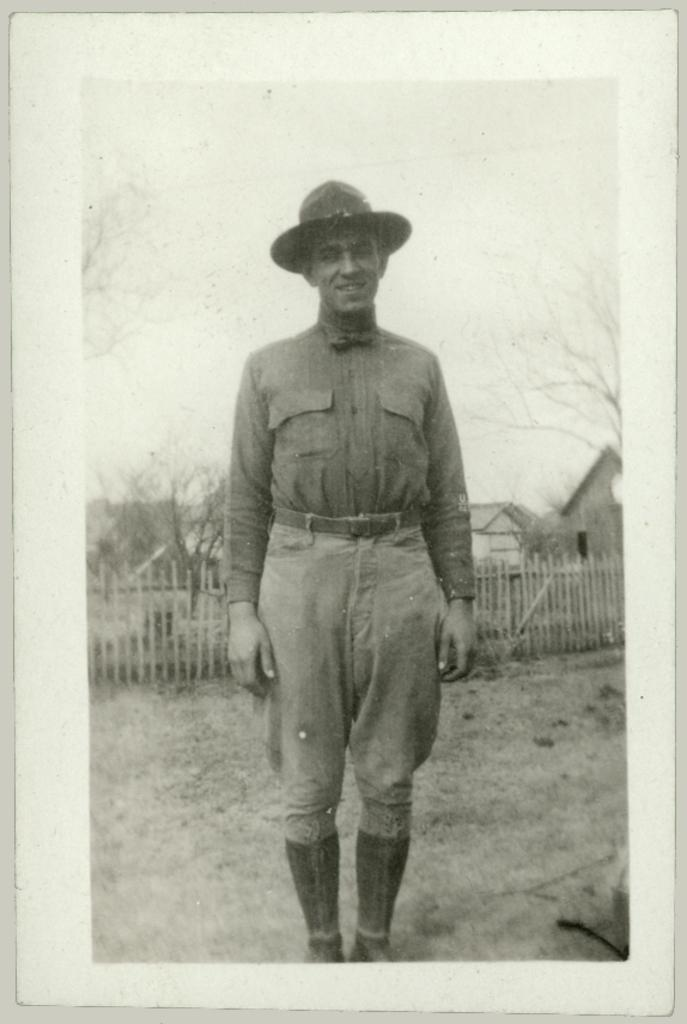What is the main subject of the image? There is a photo in the image. What can be seen in the photo? The photo contains a man standing. What is the man wearing in the photo? The man is wearing a hat. What can be seen in the background of the photo? There is a fence, houses, trees, and the sky visible in the background of the photo. How many dolls are present in the image? There are no dolls present in the image; it features a photo of a man standing. What type of voyage is the man embarking on in the image? There is no indication of a voyage in the image; it simply shows a man standing with a hat on. 